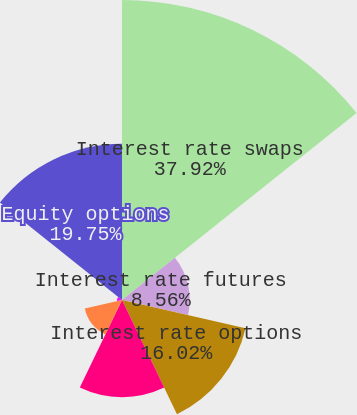Convert chart to OTSL. <chart><loc_0><loc_0><loc_500><loc_500><pie_chart><fcel>Interest rate swaps<fcel>Interest rate futures<fcel>Interest rate options<fcel>Foreign currency swaps<fcel>Foreign currency forwards<fcel>Currency options<fcel>Equity options<nl><fcel>37.93%<fcel>8.56%<fcel>16.02%<fcel>12.29%<fcel>4.83%<fcel>0.63%<fcel>19.75%<nl></chart> 